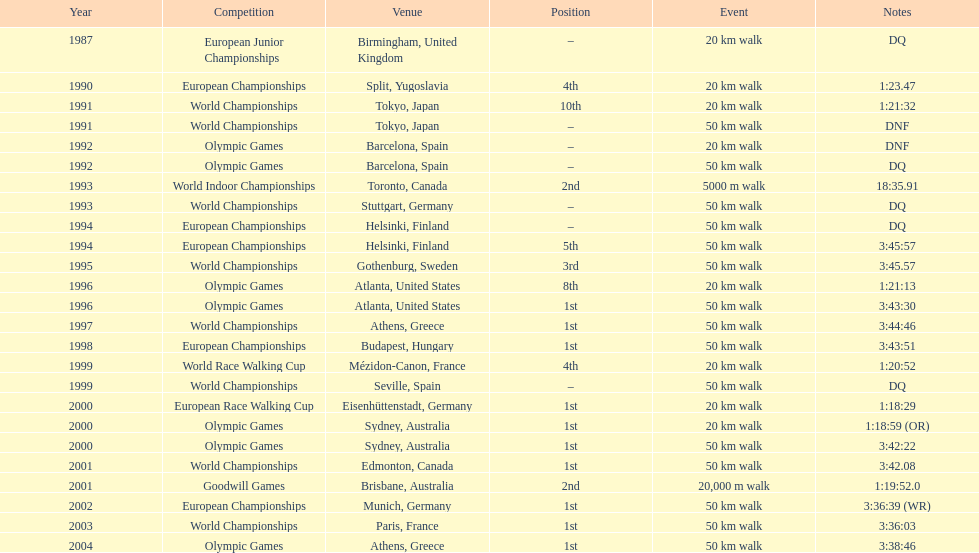How many times did korzeniowski finish above fourth place? 13. 